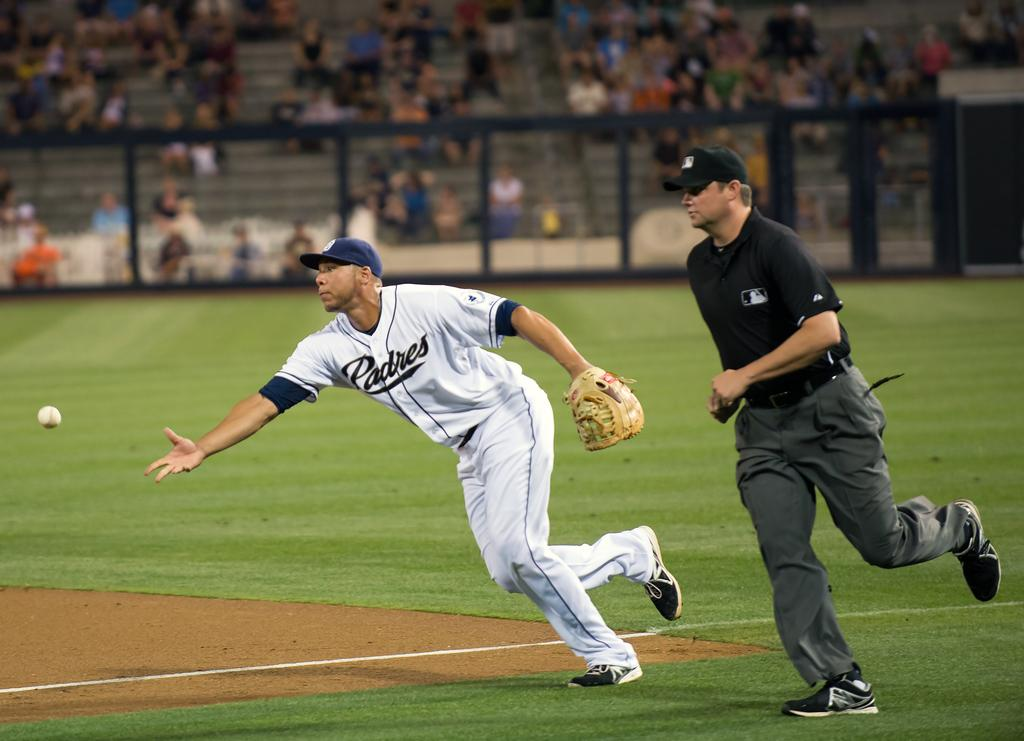<image>
Render a clear and concise summary of the photo. A player for padres throws the ball with a referee chasing behind him 